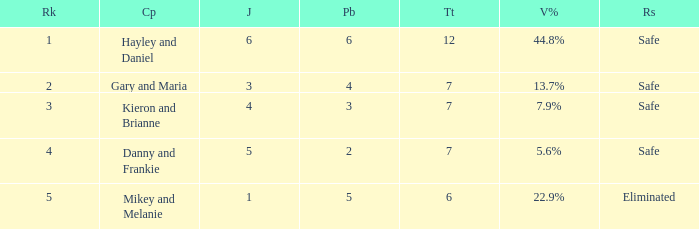What was the result for the total of 12? Safe. 